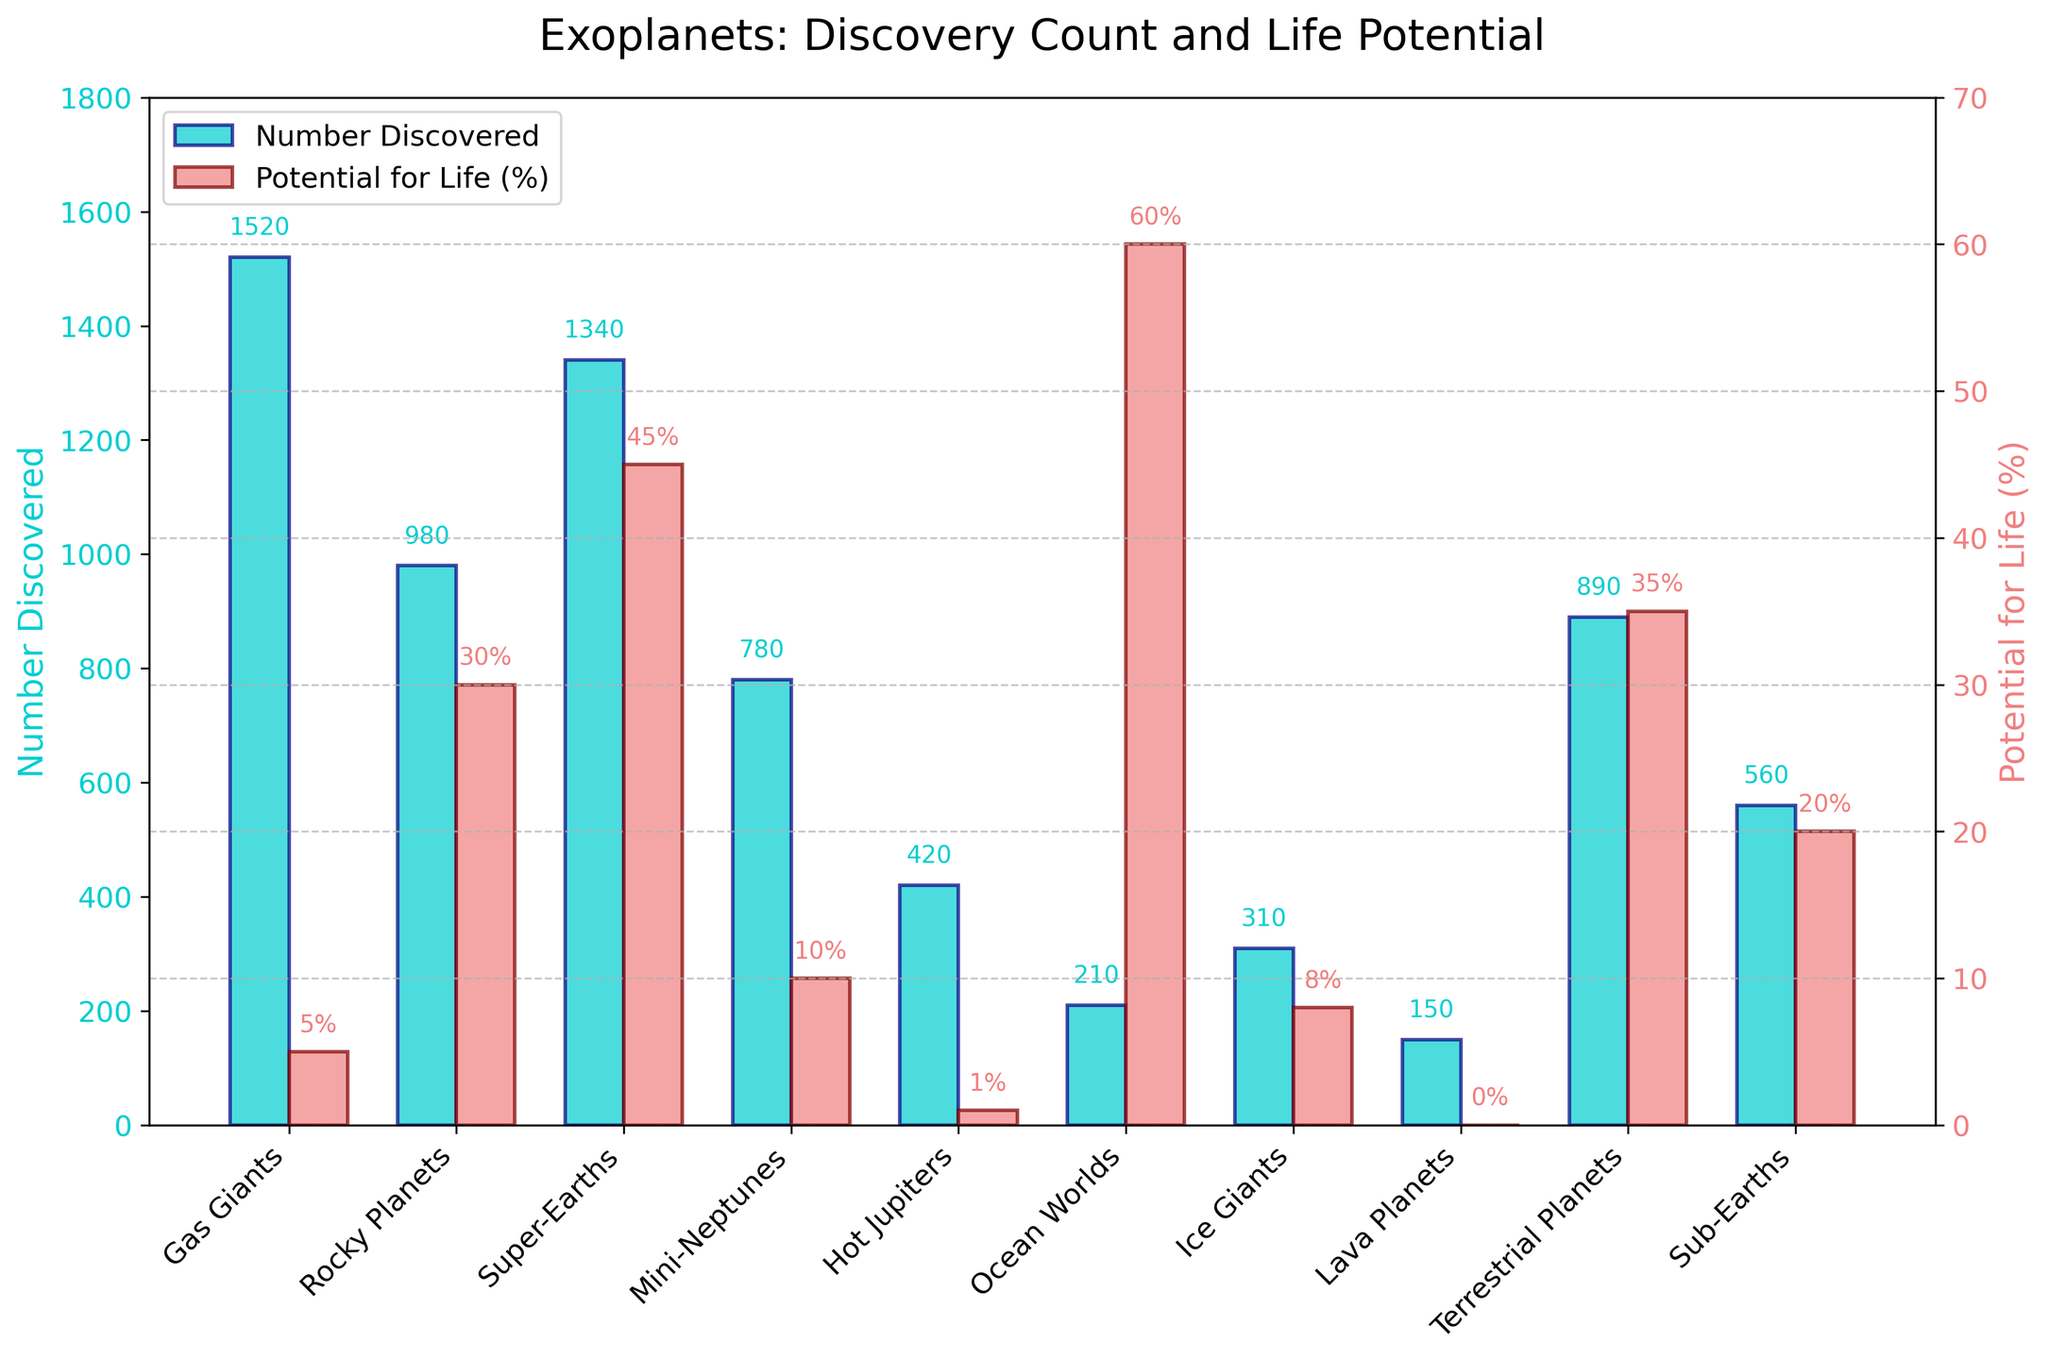Which planet type has the highest number discovered? The bar representing 'Gas Giants' reaches the highest on the chart for the number discovered, indicating it has the highest count.
Answer: Gas Giants Which planet type has the highest potential for life? The bar representing 'Ocean Worlds' reaches the highest on the chart for potential for life, indicating it has the highest percentage.
Answer: Ocean Worlds How many gas giants and rocky planets have been discovered in total? The number of gas giants is 1520 and the number of rocky planets is 980. Adding them together gives 1520 + 980 = 2500.
Answer: 2500 Which planet type has a higher potential for life, super-Earths or terrestrial planets, and by how much? 'Super-Earths' have a potential for life of 45%, while 'Terrestrial Planets' have 35%. The difference is 45% - 35% = 10%.
Answer: Super-Earths, 10% What is the average potential for life among the gas giants, hot Jupiters, and lava planets? The potentials for life are 5% for gas giants, 1% for hot Jupiters, and 0% for lava planets. The sum is 5 + 1 + 0 = 6, and the average is 6 / 3 = 2%.
Answer: 2% Which planet type has both a relatively low number discovered and high potential for life? 'Ocean Worlds' have a relatively low number discovered with 210 and a high potential for life at 60%.
Answer: Ocean Worlds Among ice giants, mini-Neptunes, and sub-Earths, which has the highest potential for life? The potential for life for ice giants is 8%, for mini-Neptunes is 10%, and for sub-Earths is 20%. The highest value is 20% for sub-Earths.
Answer: Sub-Earths What is the combined potential for life of rocky planets, super-Earths, and terrestrial planets? Rock planets have 30%, super-Earths have 45%, and terrestrial planets have 35%. The combined potential is 30 + 45 + 35 = 110%.
Answer: 110% Which planet types have a potential for life less than 10%? The bars for 'Gas Giants', 'Hot Jupiters', and 'Lava Planets' show potentials of 5%, 1%, and 0% respectively, all below 10%.
Answer: Gas Giants, Hot Jupiters, Lava Planets 